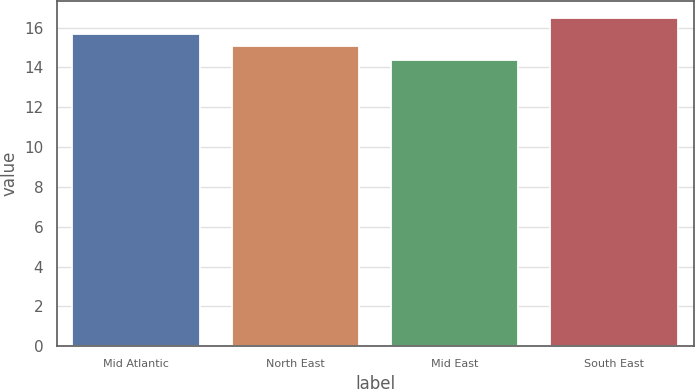<chart> <loc_0><loc_0><loc_500><loc_500><bar_chart><fcel>Mid Atlantic<fcel>North East<fcel>Mid East<fcel>South East<nl><fcel>15.7<fcel>15.1<fcel>14.4<fcel>16.5<nl></chart> 